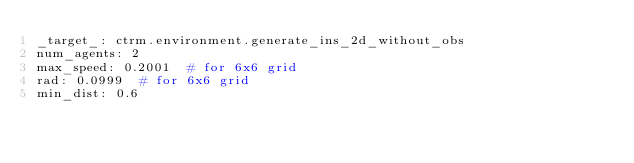Convert code to text. <code><loc_0><loc_0><loc_500><loc_500><_YAML_>_target_: ctrm.environment.generate_ins_2d_without_obs
num_agents: 2
max_speed: 0.2001  # for 6x6 grid
rad: 0.0999  # for 6x6 grid
min_dist: 0.6
</code> 